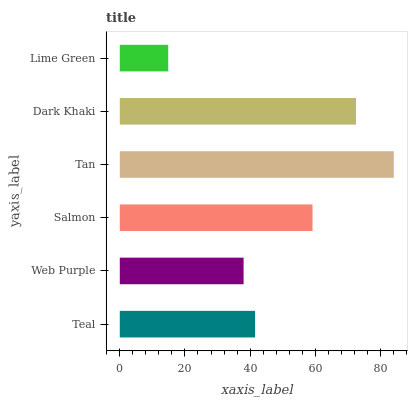Is Lime Green the minimum?
Answer yes or no. Yes. Is Tan the maximum?
Answer yes or no. Yes. Is Web Purple the minimum?
Answer yes or no. No. Is Web Purple the maximum?
Answer yes or no. No. Is Teal greater than Web Purple?
Answer yes or no. Yes. Is Web Purple less than Teal?
Answer yes or no. Yes. Is Web Purple greater than Teal?
Answer yes or no. No. Is Teal less than Web Purple?
Answer yes or no. No. Is Salmon the high median?
Answer yes or no. Yes. Is Teal the low median?
Answer yes or no. Yes. Is Lime Green the high median?
Answer yes or no. No. Is Dark Khaki the low median?
Answer yes or no. No. 